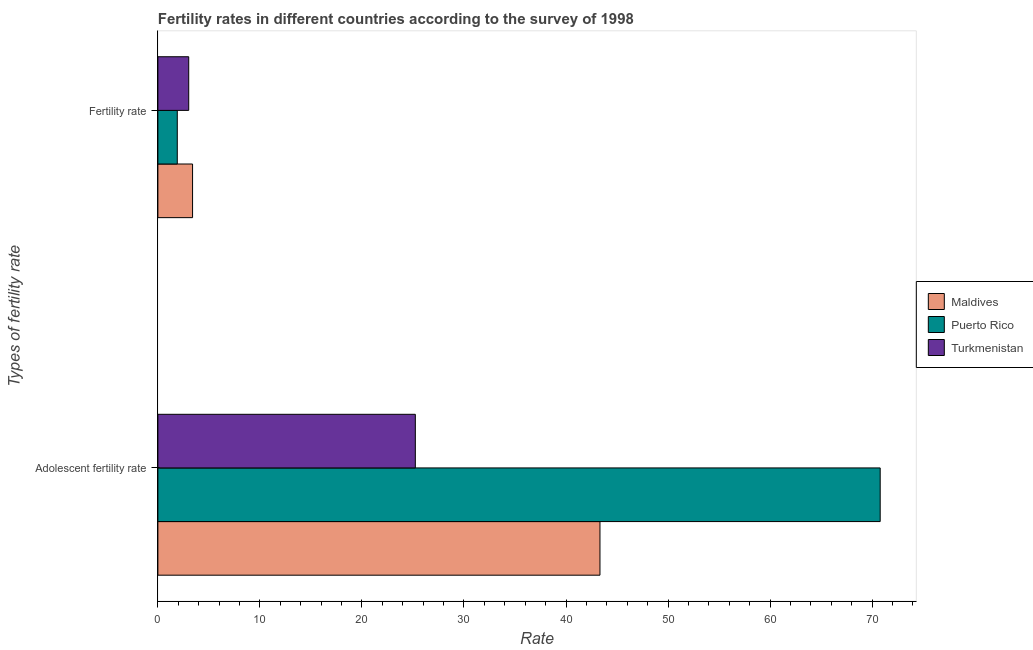How many different coloured bars are there?
Provide a short and direct response. 3. How many groups of bars are there?
Ensure brevity in your answer.  2. Are the number of bars per tick equal to the number of legend labels?
Provide a succinct answer. Yes. How many bars are there on the 1st tick from the top?
Ensure brevity in your answer.  3. What is the label of the 1st group of bars from the top?
Offer a terse response. Fertility rate. What is the fertility rate in Puerto Rico?
Provide a short and direct response. 1.9. Across all countries, what is the maximum adolescent fertility rate?
Offer a very short reply. 70.79. Across all countries, what is the minimum adolescent fertility rate?
Provide a succinct answer. 25.23. In which country was the adolescent fertility rate maximum?
Ensure brevity in your answer.  Puerto Rico. In which country was the adolescent fertility rate minimum?
Your response must be concise. Turkmenistan. What is the total adolescent fertility rate in the graph?
Offer a very short reply. 139.35. What is the difference between the adolescent fertility rate in Maldives and that in Puerto Rico?
Ensure brevity in your answer.  -27.46. What is the difference between the adolescent fertility rate in Puerto Rico and the fertility rate in Turkmenistan?
Provide a short and direct response. 67.77. What is the average fertility rate per country?
Offer a terse response. 2.77. What is the difference between the adolescent fertility rate and fertility rate in Turkmenistan?
Give a very brief answer. 22.21. In how many countries, is the fertility rate greater than 22 ?
Offer a terse response. 0. What is the ratio of the adolescent fertility rate in Turkmenistan to that in Maldives?
Provide a short and direct response. 0.58. What does the 1st bar from the top in Adolescent fertility rate represents?
Keep it short and to the point. Turkmenistan. What does the 3rd bar from the bottom in Adolescent fertility rate represents?
Keep it short and to the point. Turkmenistan. Are all the bars in the graph horizontal?
Ensure brevity in your answer.  Yes. How many countries are there in the graph?
Make the answer very short. 3. What is the difference between two consecutive major ticks on the X-axis?
Give a very brief answer. 10. Are the values on the major ticks of X-axis written in scientific E-notation?
Your answer should be very brief. No. Does the graph contain grids?
Ensure brevity in your answer.  No. Where does the legend appear in the graph?
Offer a terse response. Center right. How many legend labels are there?
Offer a very short reply. 3. How are the legend labels stacked?
Offer a very short reply. Vertical. What is the title of the graph?
Provide a succinct answer. Fertility rates in different countries according to the survey of 1998. What is the label or title of the X-axis?
Make the answer very short. Rate. What is the label or title of the Y-axis?
Give a very brief answer. Types of fertility rate. What is the Rate in Maldives in Adolescent fertility rate?
Your answer should be compact. 43.33. What is the Rate in Puerto Rico in Adolescent fertility rate?
Offer a terse response. 70.79. What is the Rate of Turkmenistan in Adolescent fertility rate?
Your answer should be compact. 25.23. What is the Rate of Maldives in Fertility rate?
Your response must be concise. 3.4. What is the Rate in Puerto Rico in Fertility rate?
Keep it short and to the point. 1.9. What is the Rate of Turkmenistan in Fertility rate?
Your answer should be compact. 3.02. Across all Types of fertility rate, what is the maximum Rate of Maldives?
Ensure brevity in your answer.  43.33. Across all Types of fertility rate, what is the maximum Rate of Puerto Rico?
Provide a short and direct response. 70.79. Across all Types of fertility rate, what is the maximum Rate of Turkmenistan?
Ensure brevity in your answer.  25.23. Across all Types of fertility rate, what is the minimum Rate in Maldives?
Keep it short and to the point. 3.4. Across all Types of fertility rate, what is the minimum Rate in Puerto Rico?
Your answer should be very brief. 1.9. Across all Types of fertility rate, what is the minimum Rate in Turkmenistan?
Give a very brief answer. 3.02. What is the total Rate in Maldives in the graph?
Offer a very short reply. 46.73. What is the total Rate of Puerto Rico in the graph?
Ensure brevity in your answer.  72.69. What is the total Rate of Turkmenistan in the graph?
Your response must be concise. 28.25. What is the difference between the Rate in Maldives in Adolescent fertility rate and that in Fertility rate?
Ensure brevity in your answer.  39.93. What is the difference between the Rate in Puerto Rico in Adolescent fertility rate and that in Fertility rate?
Provide a short and direct response. 68.89. What is the difference between the Rate of Turkmenistan in Adolescent fertility rate and that in Fertility rate?
Give a very brief answer. 22.21. What is the difference between the Rate of Maldives in Adolescent fertility rate and the Rate of Puerto Rico in Fertility rate?
Your response must be concise. 41.43. What is the difference between the Rate in Maldives in Adolescent fertility rate and the Rate in Turkmenistan in Fertility rate?
Ensure brevity in your answer.  40.31. What is the difference between the Rate of Puerto Rico in Adolescent fertility rate and the Rate of Turkmenistan in Fertility rate?
Keep it short and to the point. 67.77. What is the average Rate in Maldives per Types of fertility rate?
Offer a very short reply. 23.36. What is the average Rate of Puerto Rico per Types of fertility rate?
Offer a very short reply. 36.35. What is the average Rate in Turkmenistan per Types of fertility rate?
Offer a very short reply. 14.13. What is the difference between the Rate of Maldives and Rate of Puerto Rico in Adolescent fertility rate?
Your response must be concise. -27.46. What is the difference between the Rate of Maldives and Rate of Turkmenistan in Adolescent fertility rate?
Your answer should be very brief. 18.1. What is the difference between the Rate of Puerto Rico and Rate of Turkmenistan in Adolescent fertility rate?
Provide a short and direct response. 45.56. What is the difference between the Rate of Maldives and Rate of Puerto Rico in Fertility rate?
Offer a terse response. 1.5. What is the difference between the Rate in Maldives and Rate in Turkmenistan in Fertility rate?
Offer a very short reply. 0.38. What is the difference between the Rate in Puerto Rico and Rate in Turkmenistan in Fertility rate?
Offer a terse response. -1.12. What is the ratio of the Rate in Maldives in Adolescent fertility rate to that in Fertility rate?
Keep it short and to the point. 12.75. What is the ratio of the Rate in Puerto Rico in Adolescent fertility rate to that in Fertility rate?
Your answer should be compact. 37.26. What is the ratio of the Rate of Turkmenistan in Adolescent fertility rate to that in Fertility rate?
Keep it short and to the point. 8.35. What is the difference between the highest and the second highest Rate in Maldives?
Give a very brief answer. 39.93. What is the difference between the highest and the second highest Rate of Puerto Rico?
Offer a very short reply. 68.89. What is the difference between the highest and the second highest Rate in Turkmenistan?
Offer a terse response. 22.21. What is the difference between the highest and the lowest Rate of Maldives?
Keep it short and to the point. 39.93. What is the difference between the highest and the lowest Rate of Puerto Rico?
Make the answer very short. 68.89. What is the difference between the highest and the lowest Rate of Turkmenistan?
Keep it short and to the point. 22.21. 